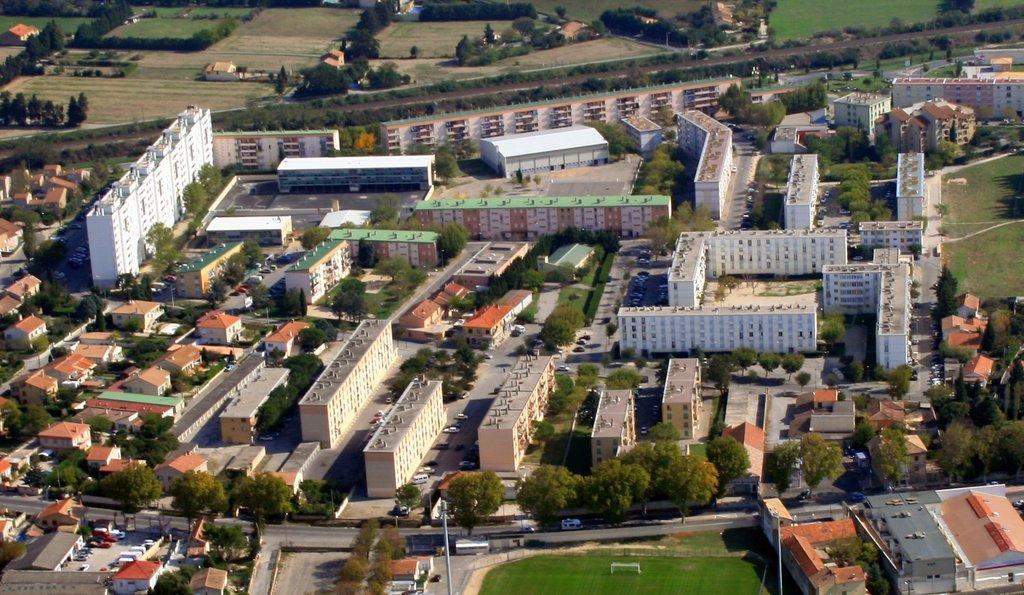In one or two sentences, can you explain what this image depicts? In the center of the image there are buildings. There is a road. There are many trees. 